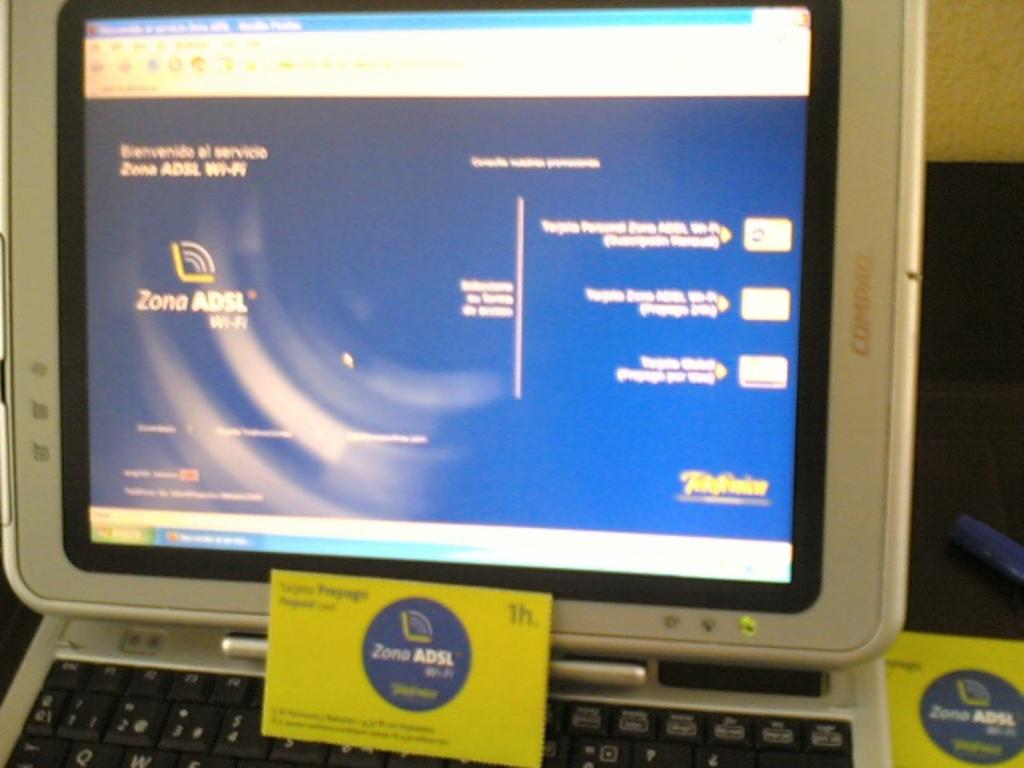How many hours is on the yellow package?
Offer a terse response. 1. 